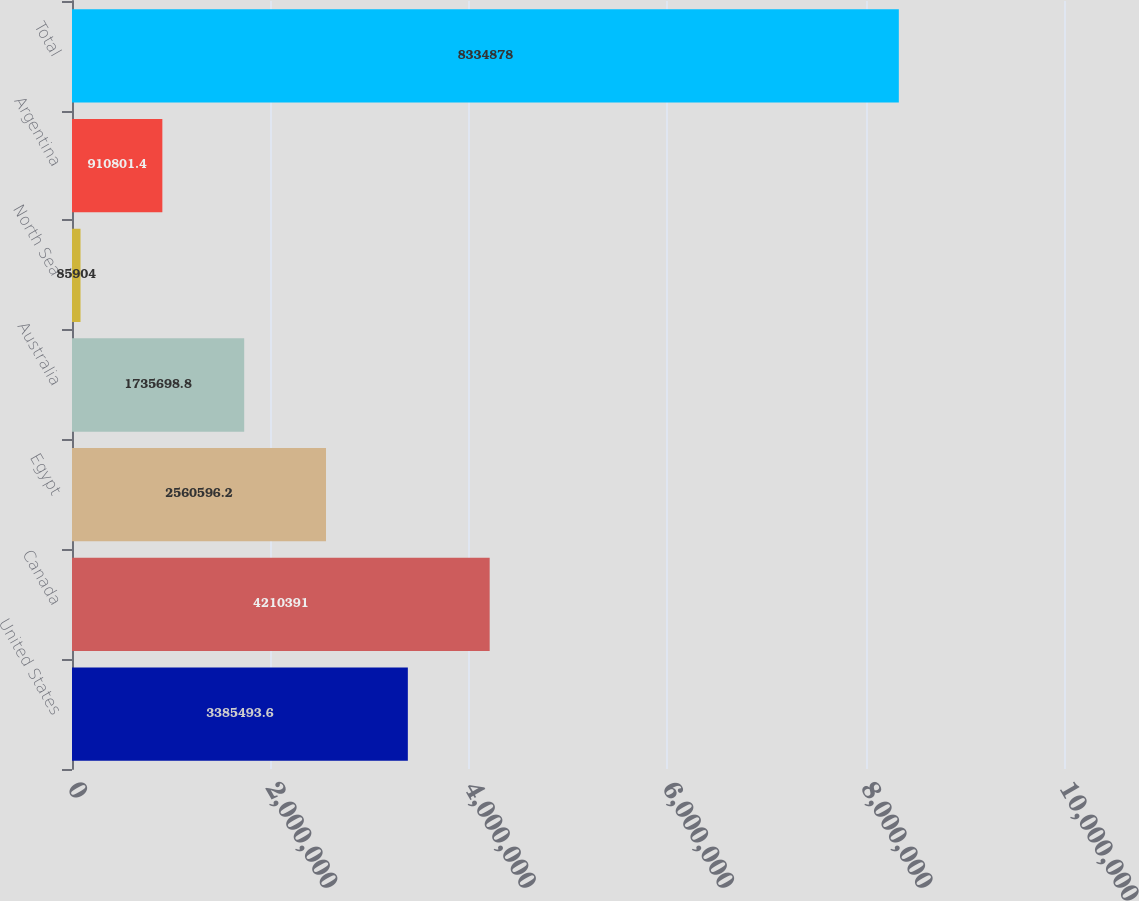<chart> <loc_0><loc_0><loc_500><loc_500><bar_chart><fcel>United States<fcel>Canada<fcel>Egypt<fcel>Australia<fcel>North Sea<fcel>Argentina<fcel>Total<nl><fcel>3.38549e+06<fcel>4.21039e+06<fcel>2.5606e+06<fcel>1.7357e+06<fcel>85904<fcel>910801<fcel>8.33488e+06<nl></chart> 